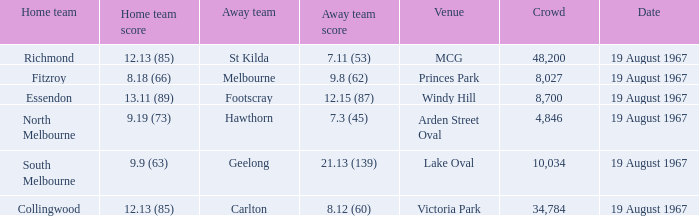What was the score for the essendon home team? 13.11 (89). 